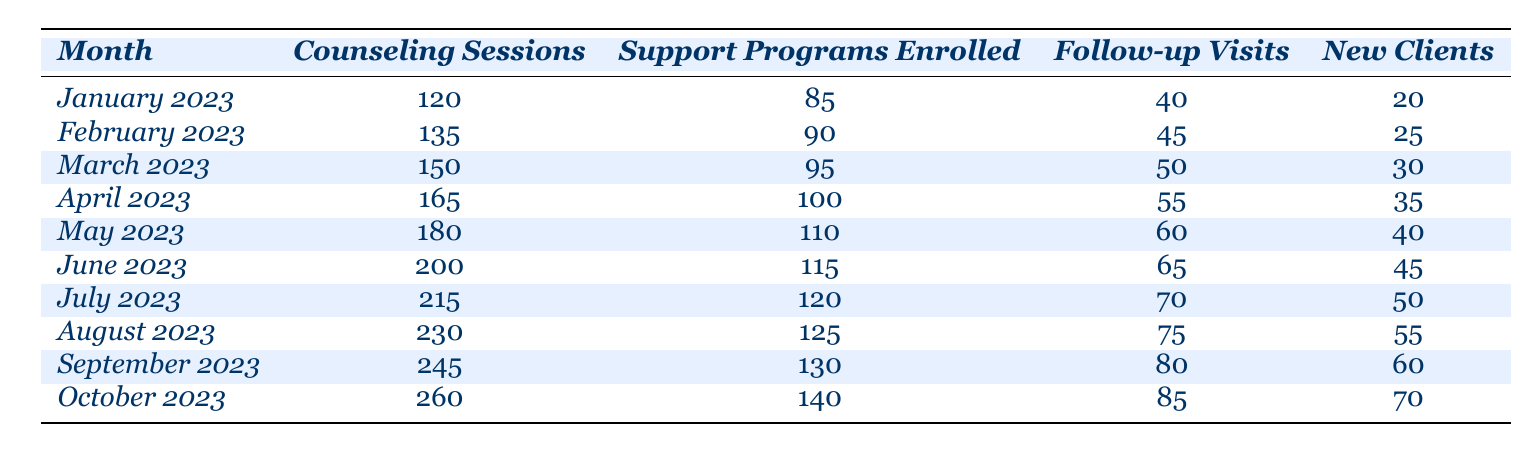What was the total number of counseling sessions conducted in March 2023? In March 2023, the table shows that there were 150 counseling sessions conducted.
Answer: 150 What month had the highest number of new clients? The table shows that October 2023 had the highest number of new clients, with a total of 70.
Answer: October 2023 What was the increase in support programs enrolled from January to October 2023? Support programs enrolled in January 2023 were 85, and in October 2023, they were 140. The increase is 140 - 85 = 55.
Answer: 55 How many follow-up visits were recorded in July 2023? According to the table, July 2023 had 70 follow-up visits recorded.
Answer: 70 What was the average number of counseling sessions from January to June 2023? To find the average, sum the counseling sessions from January to June: 120 + 135 + 150 + 165 + 180 + 200 = 1050. There are 6 months, so average is 1050 / 6 = 175.
Answer: 175 Did the number of support programs enrolled increase every month from January to October 2023? The data shows a consistent increase in the number of support programs enrolled each month from January (85) to October (140), which confirms an increase every month.
Answer: Yes What is the total number of counseling sessions from April to June 2023? The counseling sessions for April are 165, May are 180, and June are 200. Summing these values gives: 165 + 180 + 200 = 545 counseling sessions in total.
Answer: 545 How many new clients were added from February to August 2023? The new clients in February were 25, and in August, there were 55. The increase is 55 - 25 = 30 new clients added.
Answer: 30 Which month had a lower number of follow-up visits, January or March 2023? January 2023 had 40 follow-up visits and March 2023 had 50. Since 40 is less than 50, January had fewer follow-up visits.
Answer: January 2023 What is the difference in counseling sessions between the highest and lowest months recorded? The highest number of counseling sessions was in October 2023 (260), and the lowest was in January 2023 (120). The difference is 260 - 120 = 140.
Answer: 140 What was the trend in the new clients registered from January to October 2023? The number of new clients increased every month, starting from 20 in January to 70 in October, indicating a positive trend in new client registrations.
Answer: Increasing trend 